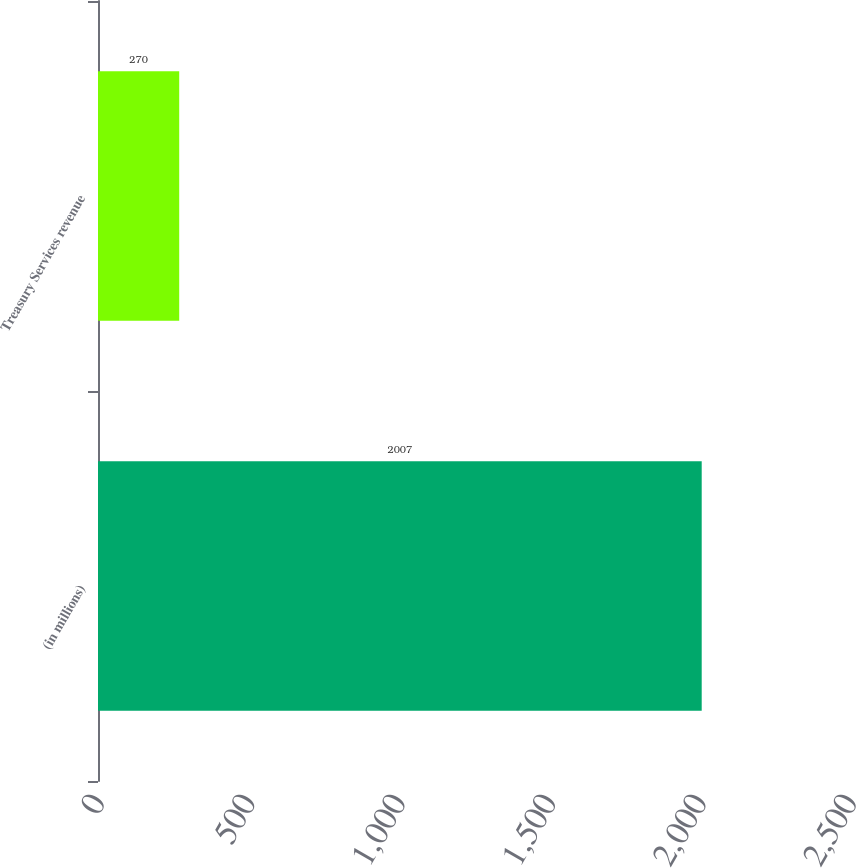Convert chart. <chart><loc_0><loc_0><loc_500><loc_500><bar_chart><fcel>(in millions)<fcel>Treasury Services revenue<nl><fcel>2007<fcel>270<nl></chart> 